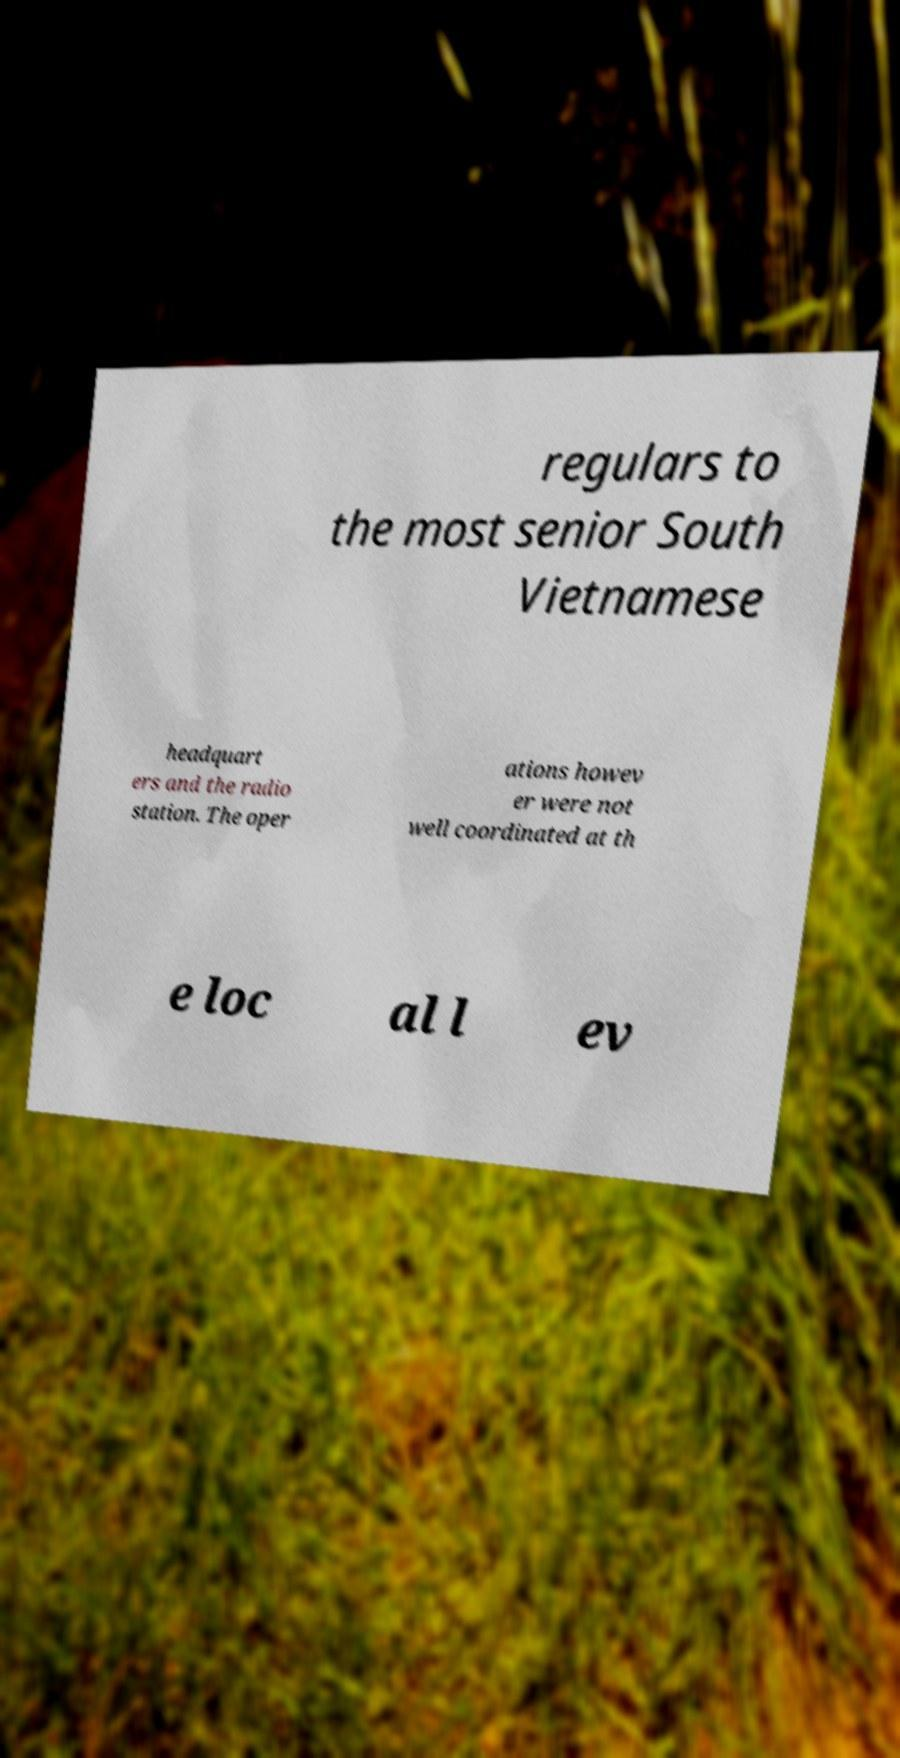Please read and relay the text visible in this image. What does it say? regulars to the most senior South Vietnamese headquart ers and the radio station. The oper ations howev er were not well coordinated at th e loc al l ev 